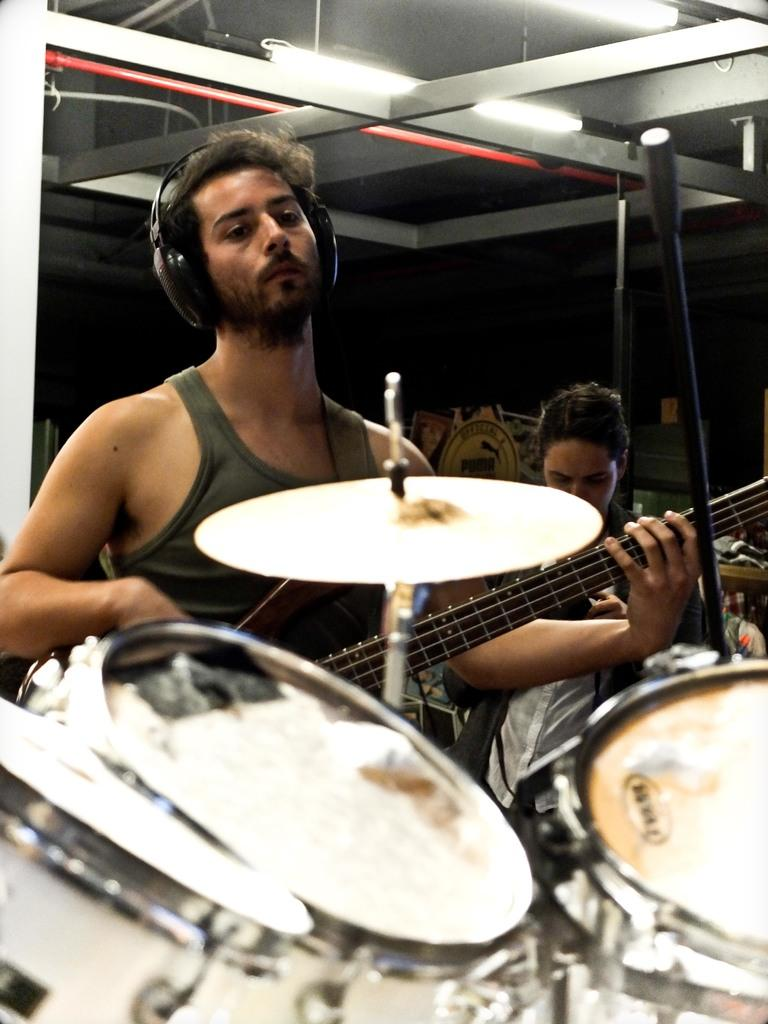What is the person in the image holding? The person is holding a guitar in the image. Can you describe the position of the woman in the image? There is a woman behind the person holding the guitar. What other musical instrument can be seen in the image? There is a musical instrument in front of the person holding the guitar. What can be seen in the background of the image? There are lights visible in the background of the image. What type of turkey is being prepared in the image? There is no turkey present in the image; it features a person holding a guitar and related elements. How many bulbs are visible in the image? There is no mention of bulbs in the image; it only mentions lights visible in the background. 